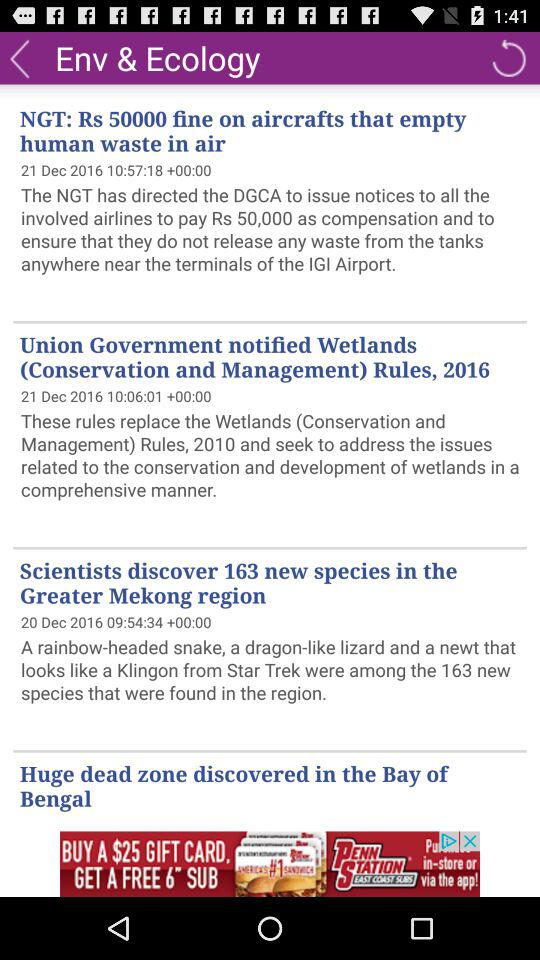When was the "Union Government notified Wetlands" news published? The "Union Government notified Wetlands" news was published on December 21, 2016 at 10:06:01. 